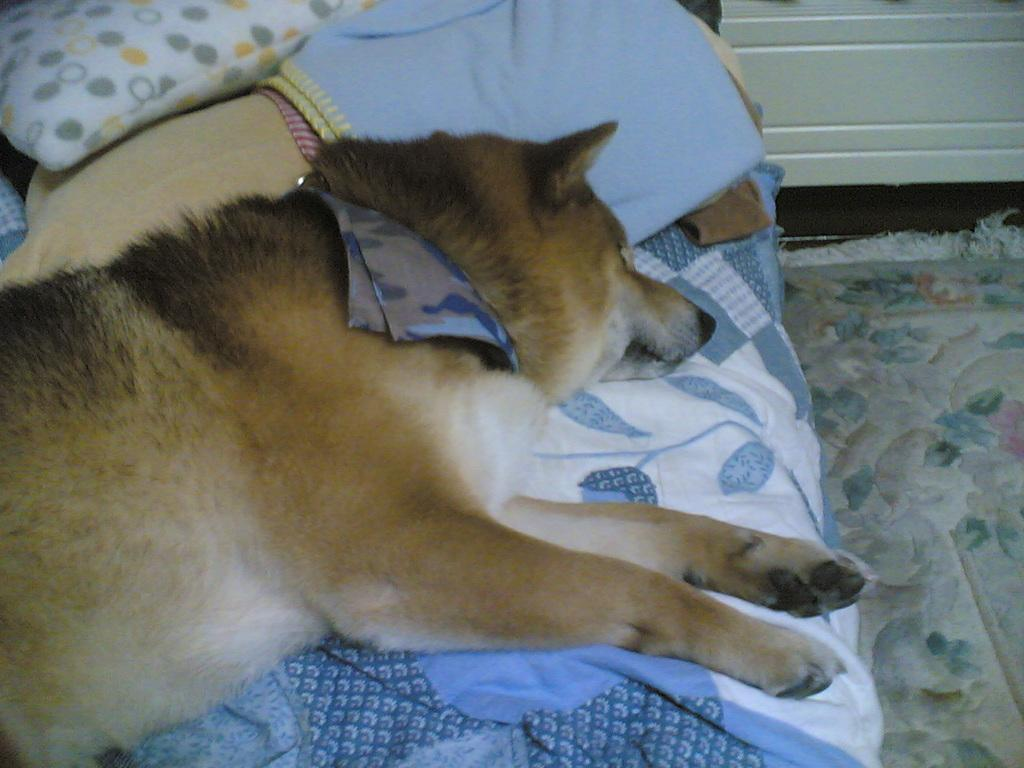What piece of furniture is present in the image? There is a bed in the image. What accessories are on the bed? There are pillows and a blanket on the bed. What type of animal is on the bed? There is a dog on the bed. Is there any other object on the right side of the image? There might be a mat on the right side of the image. What can be seen at the top right of the image? There is a wall visible at the top right of the image. What invention is being demonstrated by the dog in the image? There is no invention being demonstrated by the dog in the image; it is simply lying on the bed. Can you tell me how many pigs are present in the image? There are no pigs present in the image. 